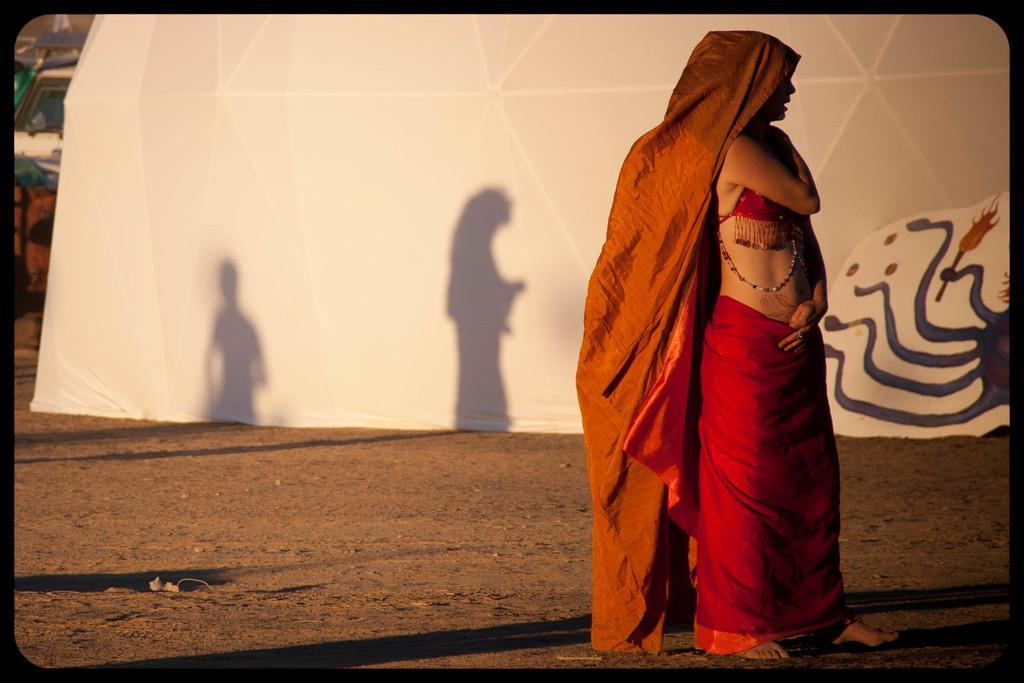Can you describe this image briefly? On the a beautiful woman is standing, she wore red color dress. 